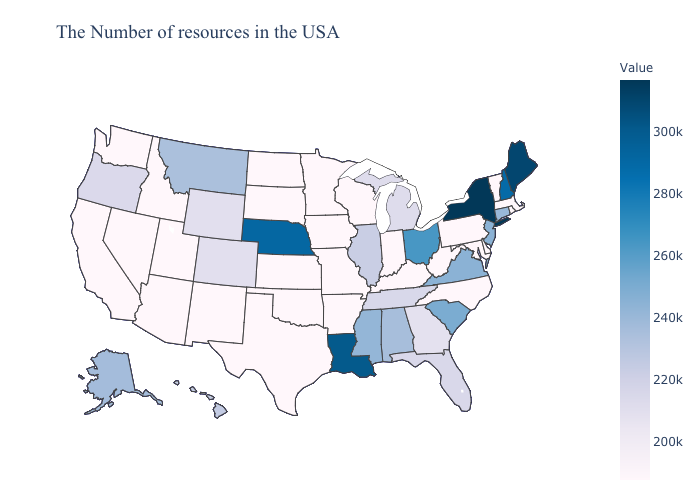Does Hawaii have a higher value than Mississippi?
Write a very short answer. No. Does Minnesota have the lowest value in the MidWest?
Keep it brief. Yes. Which states hav the highest value in the MidWest?
Be succinct. Nebraska. Which states have the highest value in the USA?
Concise answer only. New York. Which states have the lowest value in the USA?
Quick response, please. Massachusetts, Rhode Island, Vermont, Delaware, Maryland, Pennsylvania, North Carolina, West Virginia, Kentucky, Indiana, Wisconsin, Missouri, Arkansas, Minnesota, Kansas, Oklahoma, Texas, South Dakota, North Dakota, New Mexico, Utah, Arizona, Idaho, Nevada, California, Washington. 